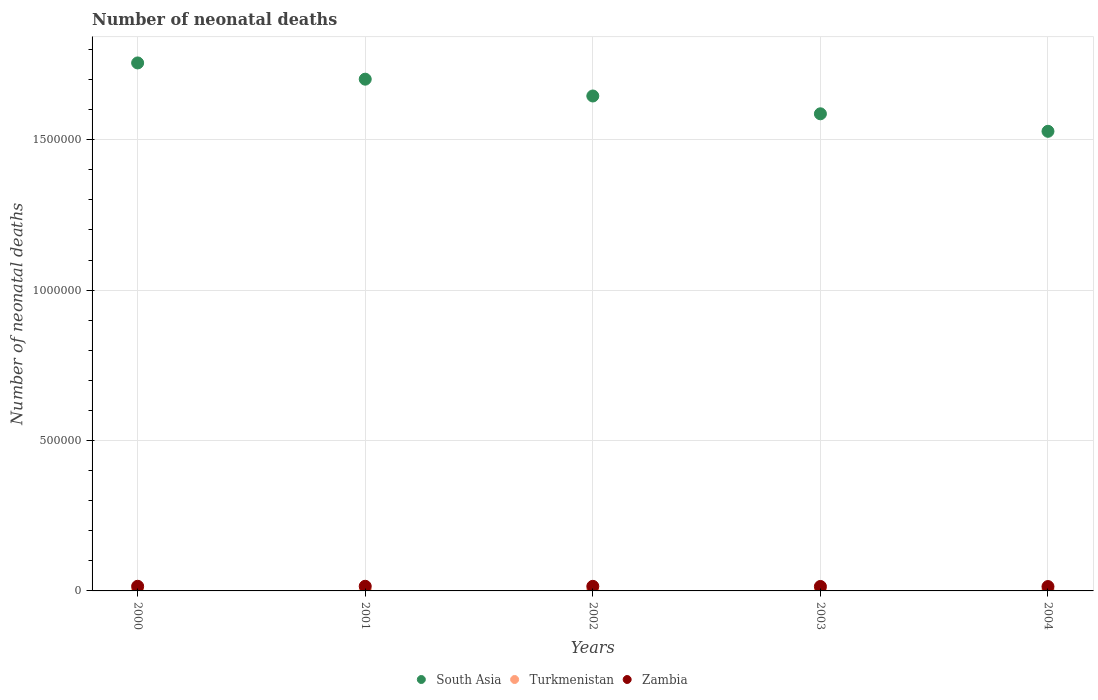What is the number of neonatal deaths in in Turkmenistan in 2002?
Provide a succinct answer. 2983. Across all years, what is the maximum number of neonatal deaths in in South Asia?
Your answer should be compact. 1.76e+06. Across all years, what is the minimum number of neonatal deaths in in Zambia?
Give a very brief answer. 1.45e+04. In which year was the number of neonatal deaths in in South Asia minimum?
Ensure brevity in your answer.  2004. What is the total number of neonatal deaths in in Zambia in the graph?
Offer a very short reply. 7.55e+04. What is the difference between the number of neonatal deaths in in Turkmenistan in 2001 and that in 2003?
Your answer should be compact. -377. What is the difference between the number of neonatal deaths in in South Asia in 2002 and the number of neonatal deaths in in Turkmenistan in 2000?
Provide a succinct answer. 1.64e+06. What is the average number of neonatal deaths in in Zambia per year?
Your response must be concise. 1.51e+04. In the year 2001, what is the difference between the number of neonatal deaths in in Zambia and number of neonatal deaths in in Turkmenistan?
Keep it short and to the point. 1.27e+04. What is the ratio of the number of neonatal deaths in in South Asia in 2000 to that in 2004?
Provide a short and direct response. 1.15. Is the number of neonatal deaths in in South Asia in 2000 less than that in 2003?
Offer a very short reply. No. Is the difference between the number of neonatal deaths in in Zambia in 2002 and 2003 greater than the difference between the number of neonatal deaths in in Turkmenistan in 2002 and 2003?
Make the answer very short. Yes. What is the difference between the highest and the second highest number of neonatal deaths in in Turkmenistan?
Ensure brevity in your answer.  152. What is the difference between the highest and the lowest number of neonatal deaths in in South Asia?
Keep it short and to the point. 2.27e+05. Does the number of neonatal deaths in in Zambia monotonically increase over the years?
Your response must be concise. No. How many years are there in the graph?
Provide a succinct answer. 5. What is the difference between two consecutive major ticks on the Y-axis?
Keep it short and to the point. 5.00e+05. Does the graph contain any zero values?
Provide a succinct answer. No. Where does the legend appear in the graph?
Provide a succinct answer. Bottom center. How are the legend labels stacked?
Offer a very short reply. Horizontal. What is the title of the graph?
Offer a very short reply. Number of neonatal deaths. Does "St. Lucia" appear as one of the legend labels in the graph?
Offer a very short reply. No. What is the label or title of the X-axis?
Your response must be concise. Years. What is the label or title of the Y-axis?
Make the answer very short. Number of neonatal deaths. What is the Number of neonatal deaths of South Asia in 2000?
Ensure brevity in your answer.  1.76e+06. What is the Number of neonatal deaths in Turkmenistan in 2000?
Ensure brevity in your answer.  2736. What is the Number of neonatal deaths of Zambia in 2000?
Make the answer very short. 1.55e+04. What is the Number of neonatal deaths of South Asia in 2001?
Your response must be concise. 1.70e+06. What is the Number of neonatal deaths of Turkmenistan in 2001?
Your answer should be compact. 2809. What is the Number of neonatal deaths of Zambia in 2001?
Give a very brief answer. 1.55e+04. What is the Number of neonatal deaths in South Asia in 2002?
Keep it short and to the point. 1.65e+06. What is the Number of neonatal deaths in Turkmenistan in 2002?
Your answer should be very brief. 2983. What is the Number of neonatal deaths in Zambia in 2002?
Your response must be concise. 1.52e+04. What is the Number of neonatal deaths of South Asia in 2003?
Your response must be concise. 1.59e+06. What is the Number of neonatal deaths in Turkmenistan in 2003?
Give a very brief answer. 3186. What is the Number of neonatal deaths of Zambia in 2003?
Give a very brief answer. 1.48e+04. What is the Number of neonatal deaths in South Asia in 2004?
Provide a succinct answer. 1.53e+06. What is the Number of neonatal deaths in Turkmenistan in 2004?
Your response must be concise. 3338. What is the Number of neonatal deaths of Zambia in 2004?
Give a very brief answer. 1.45e+04. Across all years, what is the maximum Number of neonatal deaths in South Asia?
Provide a short and direct response. 1.76e+06. Across all years, what is the maximum Number of neonatal deaths of Turkmenistan?
Provide a short and direct response. 3338. Across all years, what is the maximum Number of neonatal deaths of Zambia?
Your answer should be very brief. 1.55e+04. Across all years, what is the minimum Number of neonatal deaths of South Asia?
Provide a succinct answer. 1.53e+06. Across all years, what is the minimum Number of neonatal deaths in Turkmenistan?
Give a very brief answer. 2736. Across all years, what is the minimum Number of neonatal deaths in Zambia?
Provide a succinct answer. 1.45e+04. What is the total Number of neonatal deaths of South Asia in the graph?
Your answer should be compact. 8.22e+06. What is the total Number of neonatal deaths of Turkmenistan in the graph?
Your answer should be very brief. 1.51e+04. What is the total Number of neonatal deaths of Zambia in the graph?
Your response must be concise. 7.55e+04. What is the difference between the Number of neonatal deaths of South Asia in 2000 and that in 2001?
Provide a succinct answer. 5.40e+04. What is the difference between the Number of neonatal deaths in Turkmenistan in 2000 and that in 2001?
Your answer should be compact. -73. What is the difference between the Number of neonatal deaths of Zambia in 2000 and that in 2001?
Your answer should be very brief. -10. What is the difference between the Number of neonatal deaths in South Asia in 2000 and that in 2002?
Give a very brief answer. 1.10e+05. What is the difference between the Number of neonatal deaths of Turkmenistan in 2000 and that in 2002?
Your response must be concise. -247. What is the difference between the Number of neonatal deaths of Zambia in 2000 and that in 2002?
Offer a terse response. 211. What is the difference between the Number of neonatal deaths in South Asia in 2000 and that in 2003?
Provide a succinct answer. 1.69e+05. What is the difference between the Number of neonatal deaths of Turkmenistan in 2000 and that in 2003?
Provide a succinct answer. -450. What is the difference between the Number of neonatal deaths of Zambia in 2000 and that in 2003?
Your response must be concise. 614. What is the difference between the Number of neonatal deaths of South Asia in 2000 and that in 2004?
Give a very brief answer. 2.27e+05. What is the difference between the Number of neonatal deaths of Turkmenistan in 2000 and that in 2004?
Offer a terse response. -602. What is the difference between the Number of neonatal deaths of Zambia in 2000 and that in 2004?
Provide a short and direct response. 945. What is the difference between the Number of neonatal deaths in South Asia in 2001 and that in 2002?
Offer a terse response. 5.59e+04. What is the difference between the Number of neonatal deaths of Turkmenistan in 2001 and that in 2002?
Make the answer very short. -174. What is the difference between the Number of neonatal deaths of Zambia in 2001 and that in 2002?
Your answer should be compact. 221. What is the difference between the Number of neonatal deaths in South Asia in 2001 and that in 2003?
Make the answer very short. 1.15e+05. What is the difference between the Number of neonatal deaths in Turkmenistan in 2001 and that in 2003?
Provide a succinct answer. -377. What is the difference between the Number of neonatal deaths in Zambia in 2001 and that in 2003?
Offer a very short reply. 624. What is the difference between the Number of neonatal deaths in South Asia in 2001 and that in 2004?
Your answer should be compact. 1.73e+05. What is the difference between the Number of neonatal deaths in Turkmenistan in 2001 and that in 2004?
Make the answer very short. -529. What is the difference between the Number of neonatal deaths of Zambia in 2001 and that in 2004?
Give a very brief answer. 955. What is the difference between the Number of neonatal deaths in South Asia in 2002 and that in 2003?
Your answer should be compact. 5.92e+04. What is the difference between the Number of neonatal deaths of Turkmenistan in 2002 and that in 2003?
Provide a succinct answer. -203. What is the difference between the Number of neonatal deaths in Zambia in 2002 and that in 2003?
Your response must be concise. 403. What is the difference between the Number of neonatal deaths in South Asia in 2002 and that in 2004?
Your answer should be very brief. 1.17e+05. What is the difference between the Number of neonatal deaths in Turkmenistan in 2002 and that in 2004?
Give a very brief answer. -355. What is the difference between the Number of neonatal deaths in Zambia in 2002 and that in 2004?
Offer a very short reply. 734. What is the difference between the Number of neonatal deaths of South Asia in 2003 and that in 2004?
Your answer should be very brief. 5.82e+04. What is the difference between the Number of neonatal deaths in Turkmenistan in 2003 and that in 2004?
Keep it short and to the point. -152. What is the difference between the Number of neonatal deaths of Zambia in 2003 and that in 2004?
Give a very brief answer. 331. What is the difference between the Number of neonatal deaths in South Asia in 2000 and the Number of neonatal deaths in Turkmenistan in 2001?
Offer a very short reply. 1.75e+06. What is the difference between the Number of neonatal deaths in South Asia in 2000 and the Number of neonatal deaths in Zambia in 2001?
Your answer should be compact. 1.74e+06. What is the difference between the Number of neonatal deaths of Turkmenistan in 2000 and the Number of neonatal deaths of Zambia in 2001?
Provide a succinct answer. -1.27e+04. What is the difference between the Number of neonatal deaths in South Asia in 2000 and the Number of neonatal deaths in Turkmenistan in 2002?
Ensure brevity in your answer.  1.75e+06. What is the difference between the Number of neonatal deaths in South Asia in 2000 and the Number of neonatal deaths in Zambia in 2002?
Offer a very short reply. 1.74e+06. What is the difference between the Number of neonatal deaths of Turkmenistan in 2000 and the Number of neonatal deaths of Zambia in 2002?
Give a very brief answer. -1.25e+04. What is the difference between the Number of neonatal deaths in South Asia in 2000 and the Number of neonatal deaths in Turkmenistan in 2003?
Keep it short and to the point. 1.75e+06. What is the difference between the Number of neonatal deaths in South Asia in 2000 and the Number of neonatal deaths in Zambia in 2003?
Your answer should be compact. 1.74e+06. What is the difference between the Number of neonatal deaths in Turkmenistan in 2000 and the Number of neonatal deaths in Zambia in 2003?
Make the answer very short. -1.21e+04. What is the difference between the Number of neonatal deaths of South Asia in 2000 and the Number of neonatal deaths of Turkmenistan in 2004?
Provide a short and direct response. 1.75e+06. What is the difference between the Number of neonatal deaths in South Asia in 2000 and the Number of neonatal deaths in Zambia in 2004?
Your answer should be very brief. 1.74e+06. What is the difference between the Number of neonatal deaths of Turkmenistan in 2000 and the Number of neonatal deaths of Zambia in 2004?
Keep it short and to the point. -1.18e+04. What is the difference between the Number of neonatal deaths of South Asia in 2001 and the Number of neonatal deaths of Turkmenistan in 2002?
Provide a short and direct response. 1.70e+06. What is the difference between the Number of neonatal deaths in South Asia in 2001 and the Number of neonatal deaths in Zambia in 2002?
Your answer should be compact. 1.69e+06. What is the difference between the Number of neonatal deaths in Turkmenistan in 2001 and the Number of neonatal deaths in Zambia in 2002?
Your answer should be compact. -1.24e+04. What is the difference between the Number of neonatal deaths in South Asia in 2001 and the Number of neonatal deaths in Turkmenistan in 2003?
Give a very brief answer. 1.70e+06. What is the difference between the Number of neonatal deaths of South Asia in 2001 and the Number of neonatal deaths of Zambia in 2003?
Your response must be concise. 1.69e+06. What is the difference between the Number of neonatal deaths of Turkmenistan in 2001 and the Number of neonatal deaths of Zambia in 2003?
Offer a terse response. -1.20e+04. What is the difference between the Number of neonatal deaths in South Asia in 2001 and the Number of neonatal deaths in Turkmenistan in 2004?
Make the answer very short. 1.70e+06. What is the difference between the Number of neonatal deaths of South Asia in 2001 and the Number of neonatal deaths of Zambia in 2004?
Your answer should be compact. 1.69e+06. What is the difference between the Number of neonatal deaths in Turkmenistan in 2001 and the Number of neonatal deaths in Zambia in 2004?
Offer a very short reply. -1.17e+04. What is the difference between the Number of neonatal deaths of South Asia in 2002 and the Number of neonatal deaths of Turkmenistan in 2003?
Make the answer very short. 1.64e+06. What is the difference between the Number of neonatal deaths of South Asia in 2002 and the Number of neonatal deaths of Zambia in 2003?
Provide a short and direct response. 1.63e+06. What is the difference between the Number of neonatal deaths of Turkmenistan in 2002 and the Number of neonatal deaths of Zambia in 2003?
Make the answer very short. -1.19e+04. What is the difference between the Number of neonatal deaths in South Asia in 2002 and the Number of neonatal deaths in Turkmenistan in 2004?
Ensure brevity in your answer.  1.64e+06. What is the difference between the Number of neonatal deaths of South Asia in 2002 and the Number of neonatal deaths of Zambia in 2004?
Give a very brief answer. 1.63e+06. What is the difference between the Number of neonatal deaths in Turkmenistan in 2002 and the Number of neonatal deaths in Zambia in 2004?
Offer a terse response. -1.15e+04. What is the difference between the Number of neonatal deaths in South Asia in 2003 and the Number of neonatal deaths in Turkmenistan in 2004?
Provide a short and direct response. 1.58e+06. What is the difference between the Number of neonatal deaths in South Asia in 2003 and the Number of neonatal deaths in Zambia in 2004?
Make the answer very short. 1.57e+06. What is the difference between the Number of neonatal deaths in Turkmenistan in 2003 and the Number of neonatal deaths in Zambia in 2004?
Offer a very short reply. -1.13e+04. What is the average Number of neonatal deaths of South Asia per year?
Offer a terse response. 1.64e+06. What is the average Number of neonatal deaths in Turkmenistan per year?
Ensure brevity in your answer.  3010.4. What is the average Number of neonatal deaths in Zambia per year?
Provide a short and direct response. 1.51e+04. In the year 2000, what is the difference between the Number of neonatal deaths of South Asia and Number of neonatal deaths of Turkmenistan?
Offer a terse response. 1.75e+06. In the year 2000, what is the difference between the Number of neonatal deaths of South Asia and Number of neonatal deaths of Zambia?
Offer a terse response. 1.74e+06. In the year 2000, what is the difference between the Number of neonatal deaths in Turkmenistan and Number of neonatal deaths in Zambia?
Provide a succinct answer. -1.27e+04. In the year 2001, what is the difference between the Number of neonatal deaths of South Asia and Number of neonatal deaths of Turkmenistan?
Make the answer very short. 1.70e+06. In the year 2001, what is the difference between the Number of neonatal deaths of South Asia and Number of neonatal deaths of Zambia?
Keep it short and to the point. 1.69e+06. In the year 2001, what is the difference between the Number of neonatal deaths in Turkmenistan and Number of neonatal deaths in Zambia?
Make the answer very short. -1.27e+04. In the year 2002, what is the difference between the Number of neonatal deaths of South Asia and Number of neonatal deaths of Turkmenistan?
Offer a terse response. 1.64e+06. In the year 2002, what is the difference between the Number of neonatal deaths in South Asia and Number of neonatal deaths in Zambia?
Offer a very short reply. 1.63e+06. In the year 2002, what is the difference between the Number of neonatal deaths in Turkmenistan and Number of neonatal deaths in Zambia?
Your response must be concise. -1.23e+04. In the year 2003, what is the difference between the Number of neonatal deaths in South Asia and Number of neonatal deaths in Turkmenistan?
Your answer should be compact. 1.58e+06. In the year 2003, what is the difference between the Number of neonatal deaths of South Asia and Number of neonatal deaths of Zambia?
Your response must be concise. 1.57e+06. In the year 2003, what is the difference between the Number of neonatal deaths in Turkmenistan and Number of neonatal deaths in Zambia?
Ensure brevity in your answer.  -1.17e+04. In the year 2004, what is the difference between the Number of neonatal deaths in South Asia and Number of neonatal deaths in Turkmenistan?
Make the answer very short. 1.52e+06. In the year 2004, what is the difference between the Number of neonatal deaths in South Asia and Number of neonatal deaths in Zambia?
Your response must be concise. 1.51e+06. In the year 2004, what is the difference between the Number of neonatal deaths of Turkmenistan and Number of neonatal deaths of Zambia?
Keep it short and to the point. -1.12e+04. What is the ratio of the Number of neonatal deaths of South Asia in 2000 to that in 2001?
Your answer should be very brief. 1.03. What is the ratio of the Number of neonatal deaths of Zambia in 2000 to that in 2001?
Keep it short and to the point. 1. What is the ratio of the Number of neonatal deaths of South Asia in 2000 to that in 2002?
Provide a succinct answer. 1.07. What is the ratio of the Number of neonatal deaths of Turkmenistan in 2000 to that in 2002?
Offer a terse response. 0.92. What is the ratio of the Number of neonatal deaths in Zambia in 2000 to that in 2002?
Ensure brevity in your answer.  1.01. What is the ratio of the Number of neonatal deaths in South Asia in 2000 to that in 2003?
Provide a short and direct response. 1.11. What is the ratio of the Number of neonatal deaths of Turkmenistan in 2000 to that in 2003?
Your answer should be compact. 0.86. What is the ratio of the Number of neonatal deaths of Zambia in 2000 to that in 2003?
Your answer should be very brief. 1.04. What is the ratio of the Number of neonatal deaths of South Asia in 2000 to that in 2004?
Your answer should be very brief. 1.15. What is the ratio of the Number of neonatal deaths of Turkmenistan in 2000 to that in 2004?
Keep it short and to the point. 0.82. What is the ratio of the Number of neonatal deaths in Zambia in 2000 to that in 2004?
Your answer should be compact. 1.07. What is the ratio of the Number of neonatal deaths in South Asia in 2001 to that in 2002?
Ensure brevity in your answer.  1.03. What is the ratio of the Number of neonatal deaths in Turkmenistan in 2001 to that in 2002?
Provide a short and direct response. 0.94. What is the ratio of the Number of neonatal deaths in Zambia in 2001 to that in 2002?
Offer a terse response. 1.01. What is the ratio of the Number of neonatal deaths of South Asia in 2001 to that in 2003?
Offer a very short reply. 1.07. What is the ratio of the Number of neonatal deaths of Turkmenistan in 2001 to that in 2003?
Your answer should be very brief. 0.88. What is the ratio of the Number of neonatal deaths of Zambia in 2001 to that in 2003?
Give a very brief answer. 1.04. What is the ratio of the Number of neonatal deaths of South Asia in 2001 to that in 2004?
Provide a succinct answer. 1.11. What is the ratio of the Number of neonatal deaths of Turkmenistan in 2001 to that in 2004?
Your response must be concise. 0.84. What is the ratio of the Number of neonatal deaths in Zambia in 2001 to that in 2004?
Provide a short and direct response. 1.07. What is the ratio of the Number of neonatal deaths in South Asia in 2002 to that in 2003?
Your answer should be compact. 1.04. What is the ratio of the Number of neonatal deaths in Turkmenistan in 2002 to that in 2003?
Your answer should be compact. 0.94. What is the ratio of the Number of neonatal deaths of Zambia in 2002 to that in 2003?
Ensure brevity in your answer.  1.03. What is the ratio of the Number of neonatal deaths of South Asia in 2002 to that in 2004?
Give a very brief answer. 1.08. What is the ratio of the Number of neonatal deaths of Turkmenistan in 2002 to that in 2004?
Make the answer very short. 0.89. What is the ratio of the Number of neonatal deaths of Zambia in 2002 to that in 2004?
Offer a terse response. 1.05. What is the ratio of the Number of neonatal deaths of South Asia in 2003 to that in 2004?
Provide a short and direct response. 1.04. What is the ratio of the Number of neonatal deaths in Turkmenistan in 2003 to that in 2004?
Ensure brevity in your answer.  0.95. What is the ratio of the Number of neonatal deaths in Zambia in 2003 to that in 2004?
Your answer should be very brief. 1.02. What is the difference between the highest and the second highest Number of neonatal deaths of South Asia?
Your response must be concise. 5.40e+04. What is the difference between the highest and the second highest Number of neonatal deaths in Turkmenistan?
Your answer should be very brief. 152. What is the difference between the highest and the second highest Number of neonatal deaths in Zambia?
Give a very brief answer. 10. What is the difference between the highest and the lowest Number of neonatal deaths in South Asia?
Provide a succinct answer. 2.27e+05. What is the difference between the highest and the lowest Number of neonatal deaths of Turkmenistan?
Your response must be concise. 602. What is the difference between the highest and the lowest Number of neonatal deaths in Zambia?
Provide a short and direct response. 955. 